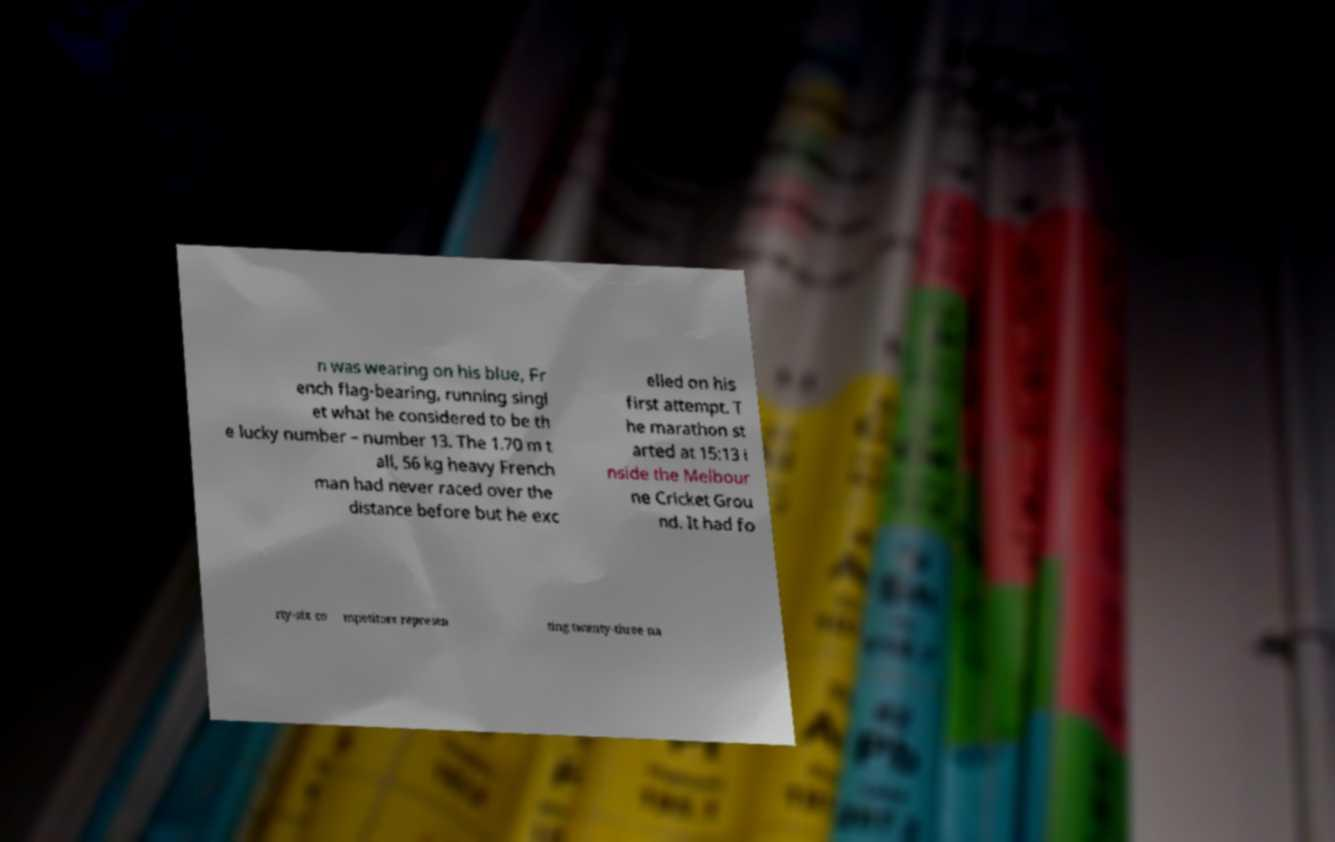Can you read and provide the text displayed in the image?This photo seems to have some interesting text. Can you extract and type it out for me? n was wearing on his blue, Fr ench flag-bearing, running singl et what he considered to be th e lucky number – number 13. The 1.70 m t all, 56 kg heavy French man had never raced over the distance before but he exc elled on his first attempt. T he marathon st arted at 15:13 i nside the Melbour ne Cricket Grou nd. It had fo rty-six co mpetitors represen ting twenty-three na 